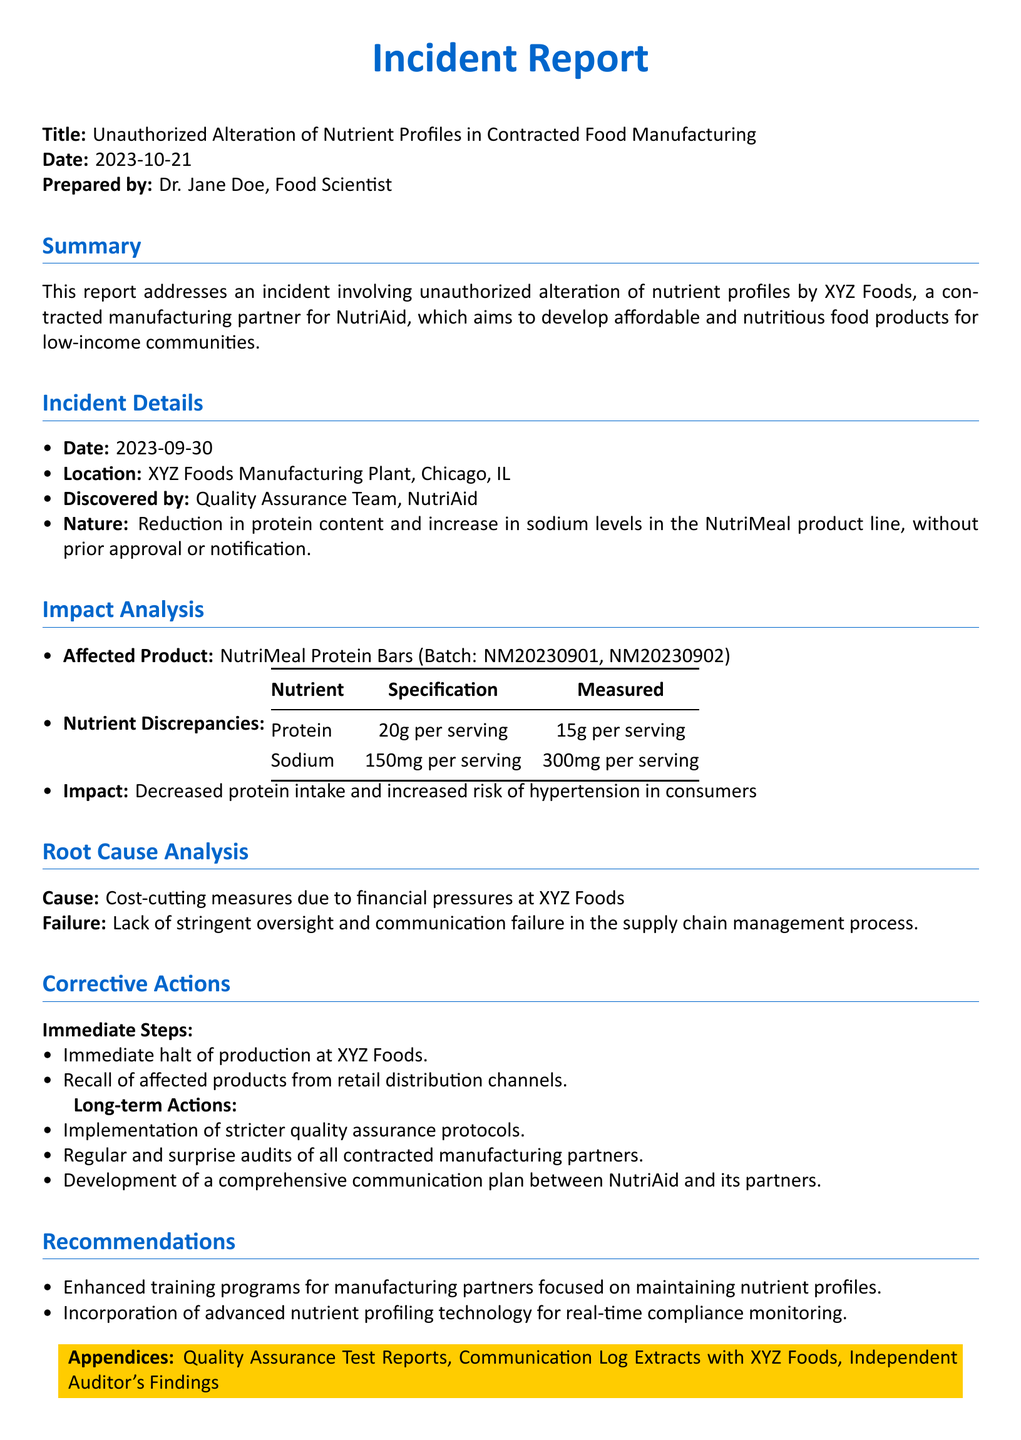What is the date of the incident? The date of the incident is mentioned in the "Incident Details" section of the document.
Answer: 2023-09-30 Who discovered the unauthorized alterations? The "Discovered by" section identifies the team responsible for discovering the issue.
Answer: Quality Assurance Team, NutriAid What nutrient was reduced in the NutriMeal product line? The "Nutrient Discrepancies" table specifies which nutrient experienced a reduction in content.
Answer: Protein What was the measured sodium level per serving? The "Nutrient Discrepancies" table provides the specific measured sodium content.
Answer: 300mg per serving What immediate step was taken regarding production? The "Corrective Actions" section outlines the first immediate action taken in response to the incident.
Answer: Immediate halt of production at XYZ Foods What is the cause of the unauthorized alteration? The "Root Cause Analysis" summarizes the underlying reason for the incident.
Answer: Cost-cutting measures What are the long-term actions recommended? The "Long-term Actions" section lists the strategies for preventing future incidents.
Answer: Implementation of stricter quality assurance protocols What is one recommendation for manufacturing partners? The "Recommendations" section outlines suggested improvements for manufacturing compliance.
Answer: Enhanced training programs for manufacturing partners 